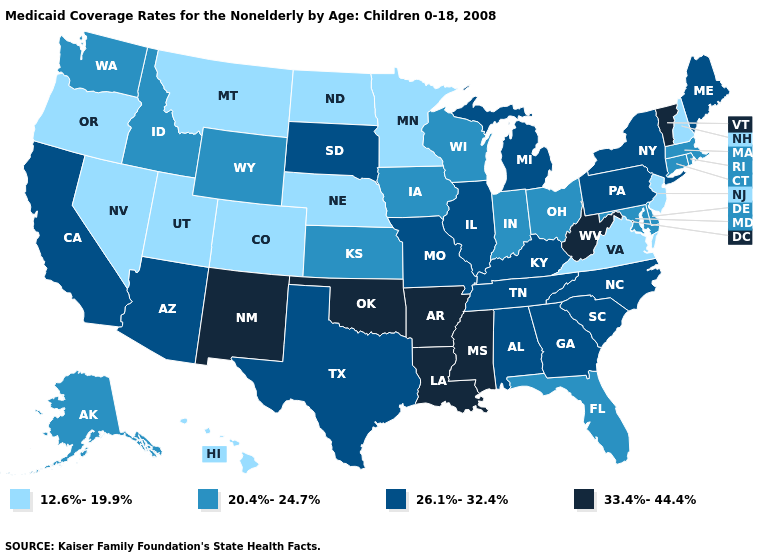Among the states that border North Dakota , which have the highest value?
Short answer required. South Dakota. What is the lowest value in the USA?
Give a very brief answer. 12.6%-19.9%. Is the legend a continuous bar?
Quick response, please. No. Does South Dakota have a higher value than Maryland?
Quick response, please. Yes. Which states hav the highest value in the Northeast?
Keep it brief. Vermont. Does Idaho have the highest value in the West?
Answer briefly. No. Which states have the lowest value in the Northeast?
Be succinct. New Hampshire, New Jersey. What is the value of Montana?
Quick response, please. 12.6%-19.9%. Name the states that have a value in the range 20.4%-24.7%?
Short answer required. Alaska, Connecticut, Delaware, Florida, Idaho, Indiana, Iowa, Kansas, Maryland, Massachusetts, Ohio, Rhode Island, Washington, Wisconsin, Wyoming. Which states have the lowest value in the USA?
Concise answer only. Colorado, Hawaii, Minnesota, Montana, Nebraska, Nevada, New Hampshire, New Jersey, North Dakota, Oregon, Utah, Virginia. Does the first symbol in the legend represent the smallest category?
Write a very short answer. Yes. Which states hav the highest value in the South?
Be succinct. Arkansas, Louisiana, Mississippi, Oklahoma, West Virginia. How many symbols are there in the legend?
Give a very brief answer. 4. Name the states that have a value in the range 26.1%-32.4%?
Write a very short answer. Alabama, Arizona, California, Georgia, Illinois, Kentucky, Maine, Michigan, Missouri, New York, North Carolina, Pennsylvania, South Carolina, South Dakota, Tennessee, Texas. Which states have the lowest value in the USA?
Quick response, please. Colorado, Hawaii, Minnesota, Montana, Nebraska, Nevada, New Hampshire, New Jersey, North Dakota, Oregon, Utah, Virginia. 